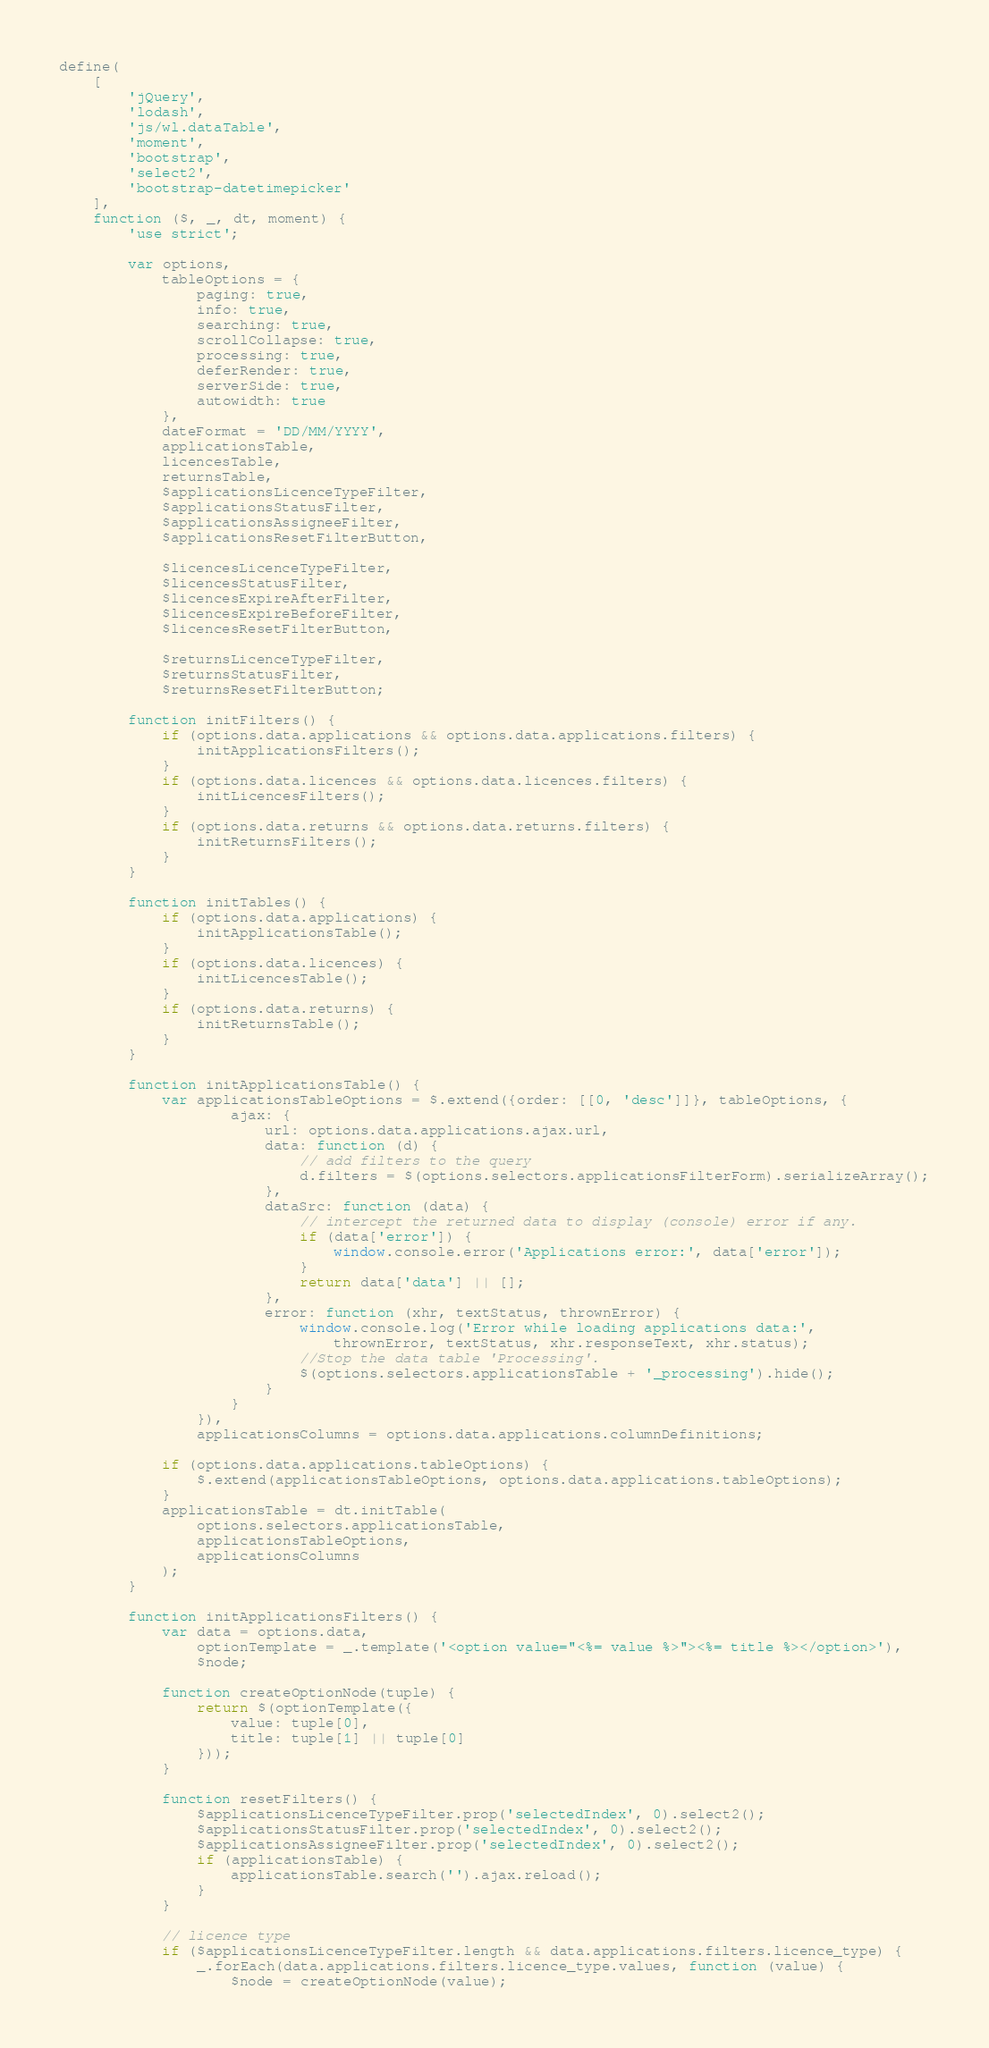<code> <loc_0><loc_0><loc_500><loc_500><_JavaScript_>define(
    [
        'jQuery',
        'lodash',
        'js/wl.dataTable',
        'moment',
        'bootstrap',
        'select2',
        'bootstrap-datetimepicker'
    ],
    function ($, _, dt, moment) {
        'use strict';

        var options,
            tableOptions = {
                paging: true,
                info: true,
                searching: true,
                scrollCollapse: true,
                processing: true,
                deferRender: true,
                serverSide: true,
                autowidth: true
            },
            dateFormat = 'DD/MM/YYYY',
            applicationsTable,
            licencesTable,
            returnsTable,
            $applicationsLicenceTypeFilter,
            $applicationsStatusFilter,
            $applicationsAssigneeFilter,
            $applicationsResetFilterButton,

            $licencesLicenceTypeFilter,
            $licencesStatusFilter,
            $licencesExpireAfterFilter,
            $licencesExpireBeforeFilter,
            $licencesResetFilterButton,

            $returnsLicenceTypeFilter,
            $returnsStatusFilter,
            $returnsResetFilterButton;

        function initFilters() {
            if (options.data.applications && options.data.applications.filters) {
                initApplicationsFilters();
            }
            if (options.data.licences && options.data.licences.filters) {
                initLicencesFilters();
            }
            if (options.data.returns && options.data.returns.filters) {
                initReturnsFilters();
            }
        }

        function initTables() {
            if (options.data.applications) {
                initApplicationsTable();
            }
            if (options.data.licences) {
                initLicencesTable();
            }
            if (options.data.returns) {
                initReturnsTable();
            }
        }

        function initApplicationsTable() {
            var applicationsTableOptions = $.extend({order: [[0, 'desc']]}, tableOptions, {
                    ajax: {
                        url: options.data.applications.ajax.url,
                        data: function (d) {
                            // add filters to the query
                            d.filters = $(options.selectors.applicationsFilterForm).serializeArray();
                        },
                        dataSrc: function (data) {
                            // intercept the returned data to display (console) error if any.
                            if (data['error']) {
                                window.console.error('Applications error:', data['error']);
                            }
                            return data['data'] || [];
                        },
                        error: function (xhr, textStatus, thrownError) {
                            window.console.log('Error while loading applications data:',
                                thrownError, textStatus, xhr.responseText, xhr.status);
                            //Stop the data table 'Processing'.
                            $(options.selectors.applicationsTable + '_processing').hide();
                        }
                    }
                }),
                applicationsColumns = options.data.applications.columnDefinitions;

            if (options.data.applications.tableOptions) {
                $.extend(applicationsTableOptions, options.data.applications.tableOptions);
            }
            applicationsTable = dt.initTable(
                options.selectors.applicationsTable,
                applicationsTableOptions,
                applicationsColumns
            );
        }

        function initApplicationsFilters() {
            var data = options.data,
                optionTemplate = _.template('<option value="<%= value %>"><%= title %></option>'),
                $node;

            function createOptionNode(tuple) {
                return $(optionTemplate({
                    value: tuple[0],
                    title: tuple[1] || tuple[0]
                }));
            }

            function resetFilters() {
                $applicationsLicenceTypeFilter.prop('selectedIndex', 0).select2();
                $applicationsStatusFilter.prop('selectedIndex', 0).select2();
                $applicationsAssigneeFilter.prop('selectedIndex', 0).select2();
                if (applicationsTable) {
                    applicationsTable.search('').ajax.reload();
                }
            }

            // licence type
            if ($applicationsLicenceTypeFilter.length && data.applications.filters.licence_type) {
                _.forEach(data.applications.filters.licence_type.values, function (value) {
                    $node = createOptionNode(value);</code> 